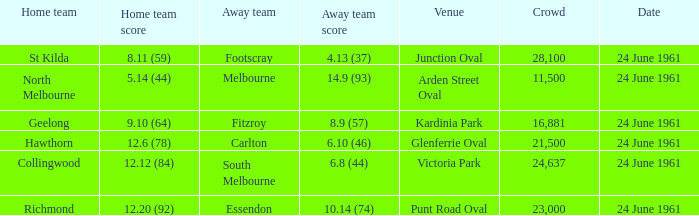What was the home team's score at the game attended by more than 24,637? 8.11 (59). 